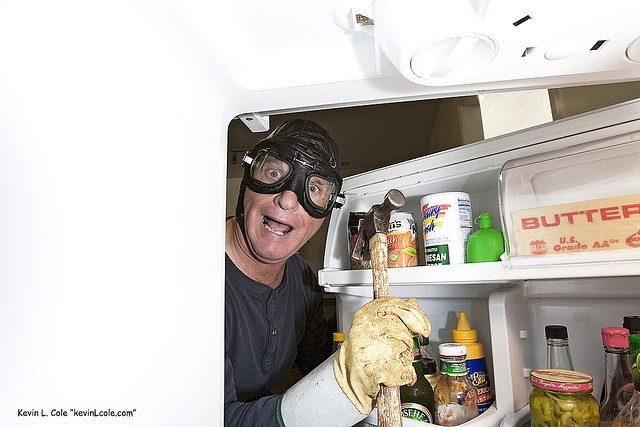Describe the objects in this image and their specific colors. I can see refrigerator in white, lightgray, darkgray, gray, and tan tones, people in white, black, ivory, khaki, and gray tones, bottle in white, olive, and brown tones, bottle in white, gray, lightgray, maroon, and tan tones, and bottle in white, black, gray, maroon, and brown tones in this image. 